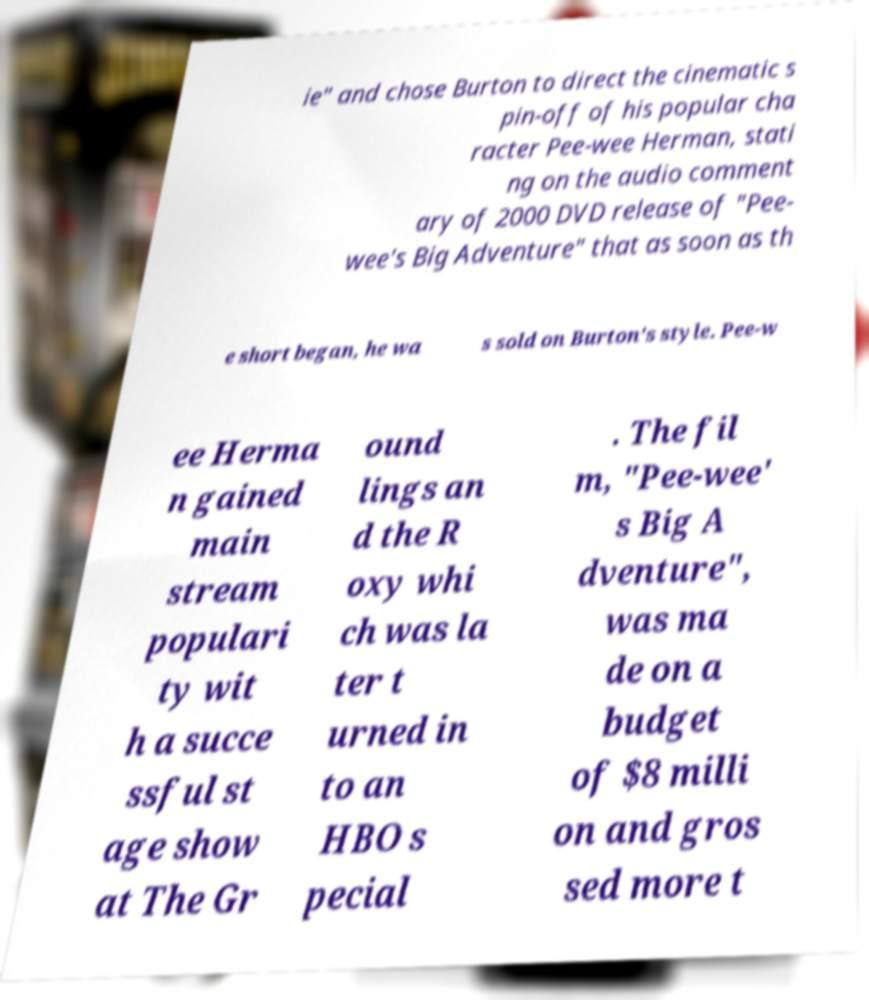There's text embedded in this image that I need extracted. Can you transcribe it verbatim? ie" and chose Burton to direct the cinematic s pin-off of his popular cha racter Pee-wee Herman, stati ng on the audio comment ary of 2000 DVD release of "Pee- wee's Big Adventure" that as soon as th e short began, he wa s sold on Burton's style. Pee-w ee Herma n gained main stream populari ty wit h a succe ssful st age show at The Gr ound lings an d the R oxy whi ch was la ter t urned in to an HBO s pecial . The fil m, "Pee-wee' s Big A dventure", was ma de on a budget of $8 milli on and gros sed more t 